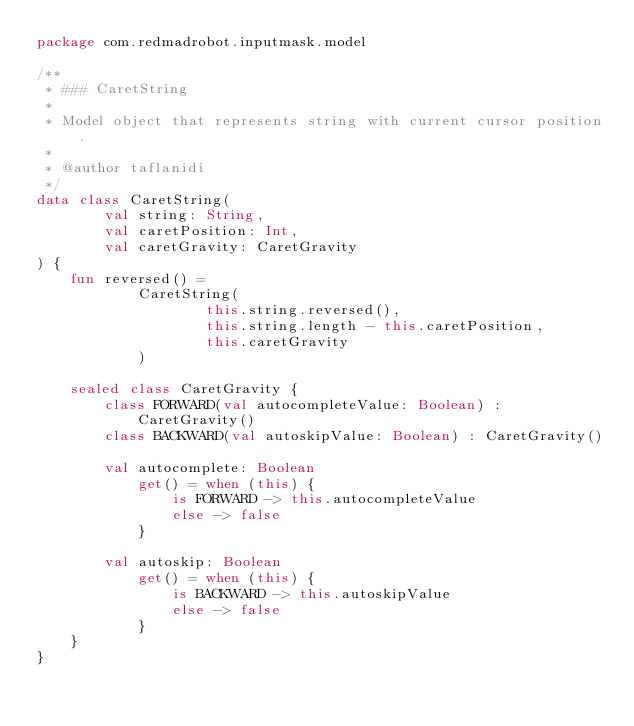Convert code to text. <code><loc_0><loc_0><loc_500><loc_500><_Kotlin_>package com.redmadrobot.inputmask.model

/**
 * ### CaretString
 *
 * Model object that represents string with current cursor position.
 *
 * @author taflanidi
 */
data class CaretString(
        val string: String,
        val caretPosition: Int,
        val caretGravity: CaretGravity
) {
    fun reversed() =
            CaretString(
                    this.string.reversed(),
                    this.string.length - this.caretPosition,
                    this.caretGravity
            )

    sealed class CaretGravity {
        class FORWARD(val autocompleteValue: Boolean) : CaretGravity()
        class BACKWARD(val autoskipValue: Boolean) : CaretGravity()

        val autocomplete: Boolean
            get() = when (this) {
                is FORWARD -> this.autocompleteValue
                else -> false
            }

        val autoskip: Boolean
            get() = when (this) {
                is BACKWARD -> this.autoskipValue
                else -> false
            }
    }
}
</code> 